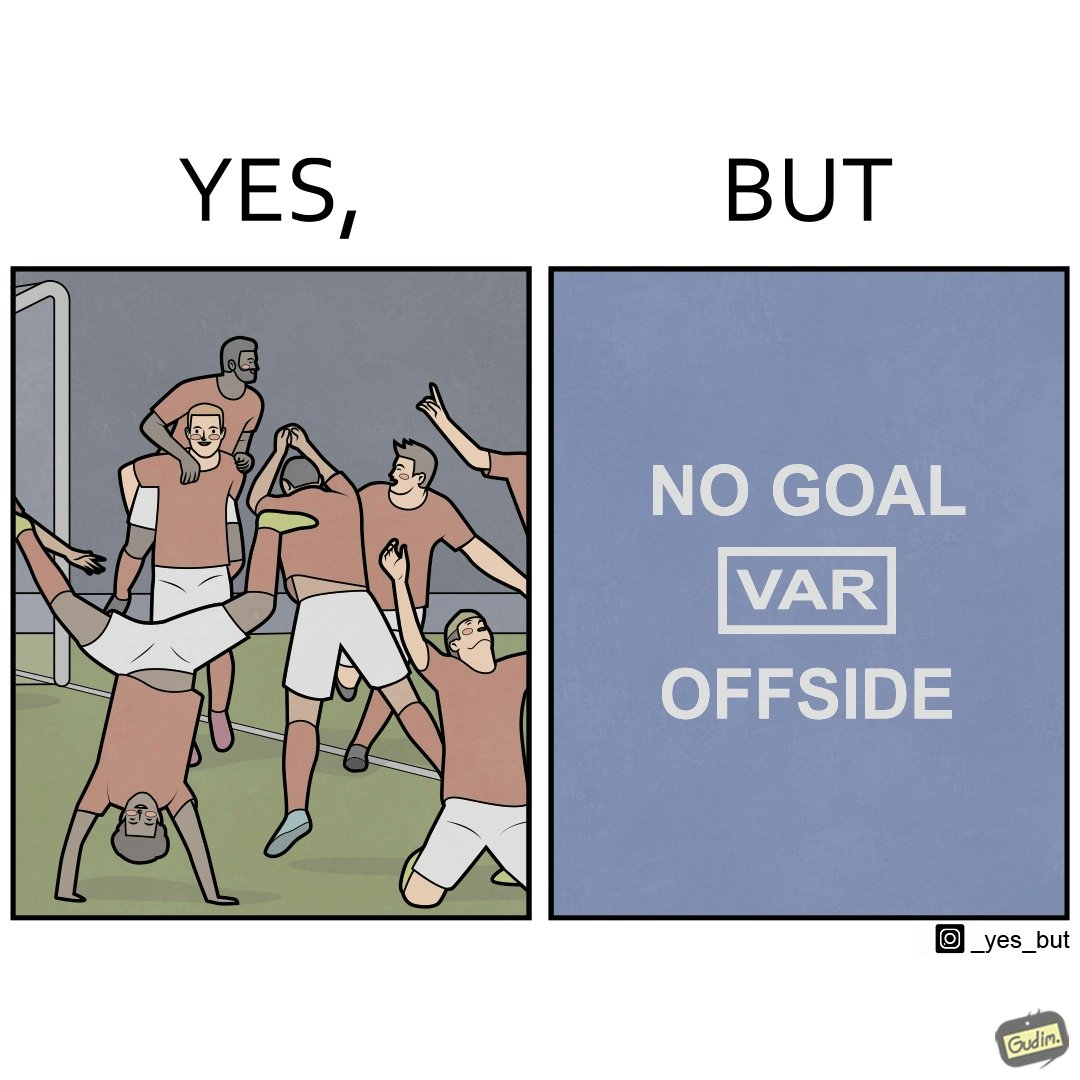What do you see in each half of this image? In the left part of the image: football players celebrating, probably due a goal their team has scored. In the right part of the image: A sign of "No goal - Offside". 